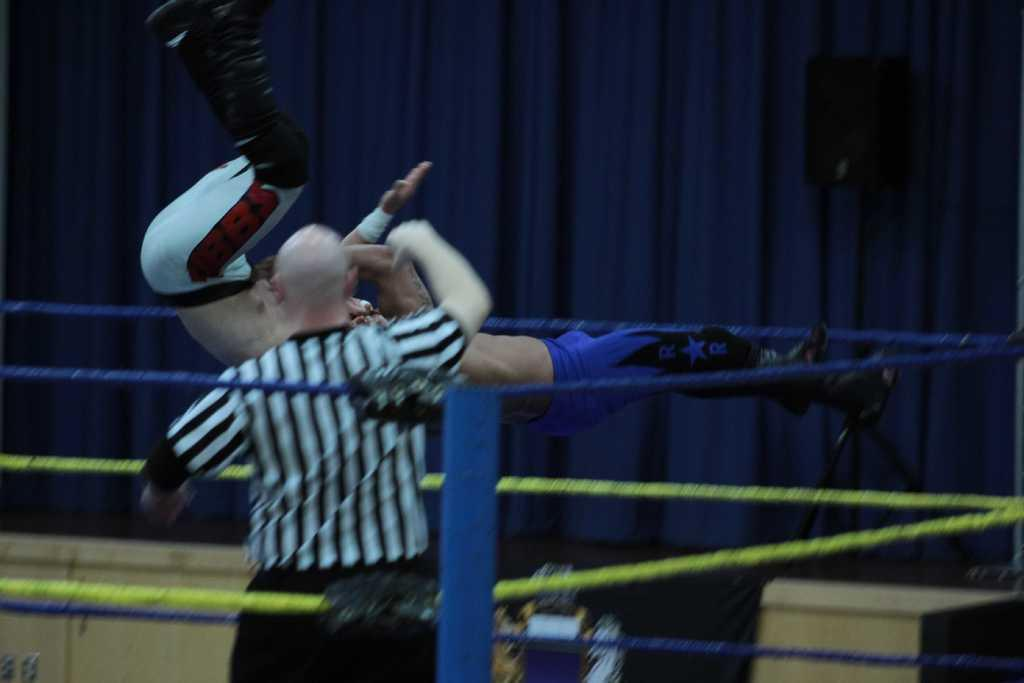How many people are in the image? There are three persons in the image. What are two of the persons doing in the image? Two of the persons are jumping above a boxing ring. What can be seen in the background of the image? There is a speaker, a pole, and curtains in the background of the image. Can you see any cobwebs in the image? There are no cobwebs present in the image. What arithmetic problem are the persons solving in the image? The image does not depict any arithmetic problems being solved; it shows two persons jumping above a boxing ring. 